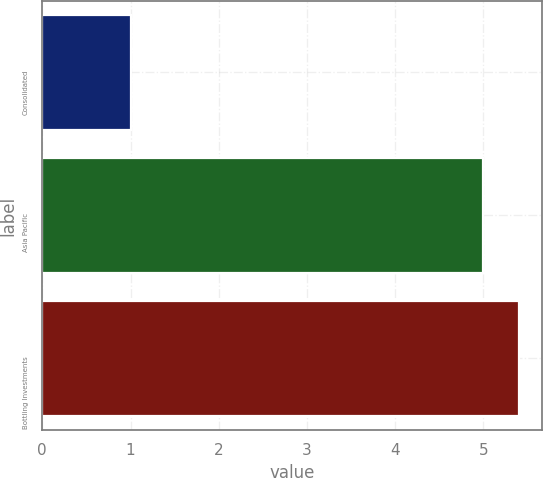<chart> <loc_0><loc_0><loc_500><loc_500><bar_chart><fcel>Consolidated<fcel>Asia Pacific<fcel>Bottling Investments<nl><fcel>1<fcel>5<fcel>5.4<nl></chart> 